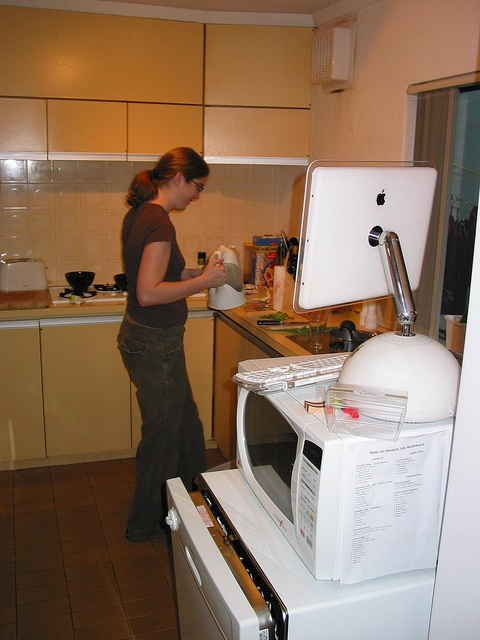Describe the objects in this image and their specific colors. I can see microwave in gray, lightgray, darkgray, and black tones, people in gray, black, maroon, and brown tones, tv in gray, lightgray, and darkgray tones, refrigerator in gray, lightgray, and maroon tones, and keyboard in gray, lightgray, and darkgray tones in this image. 